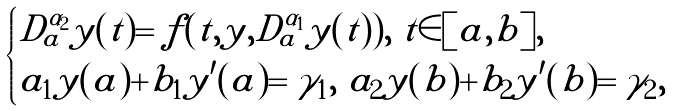<formula> <loc_0><loc_0><loc_500><loc_500>\begin{cases} D _ { a } ^ { \alpha _ { 2 } } y ( t ) = f ( t , y , D _ { a } ^ { \alpha _ { 1 } } y ( t ) ) , \ t \in [ a , b ] , \\ a _ { 1 } y ( a ) + b _ { 1 } y ^ { \prime } ( a ) = \gamma _ { 1 } , \ a _ { 2 } y ( b ) + b _ { 2 } y ^ { \prime } ( b ) = \gamma _ { 2 } , \end{cases}</formula> 